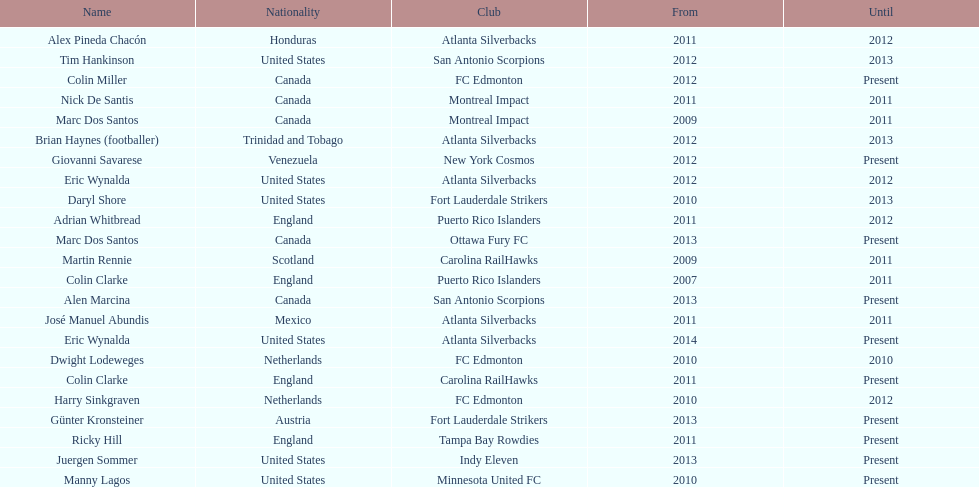What same country did marc dos santos coach as colin miller? Canada. 